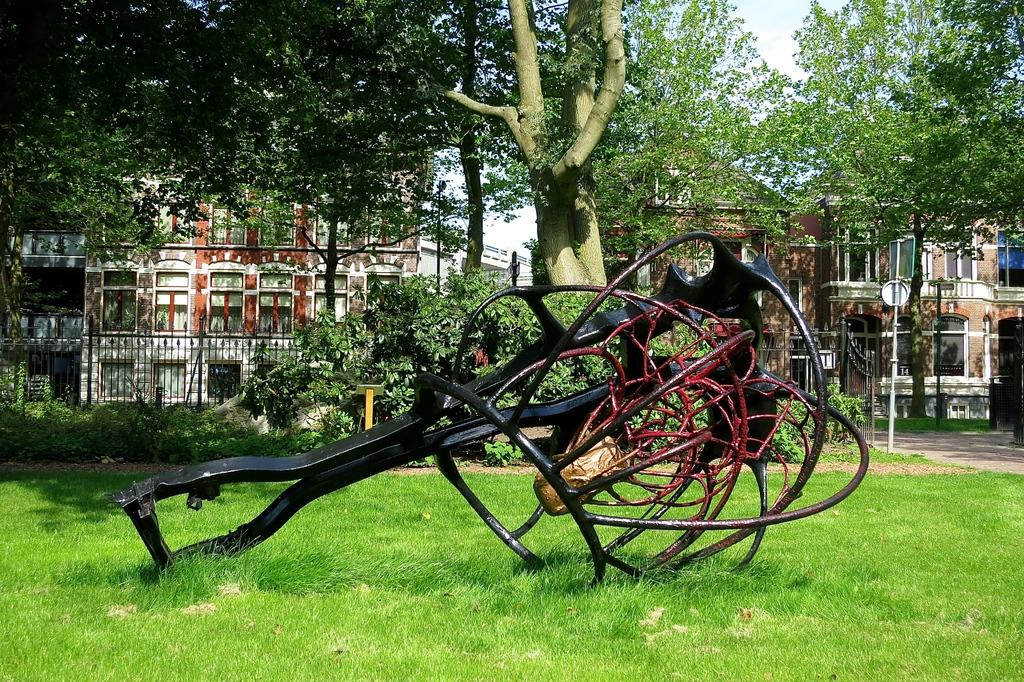What type of fence is in the image? There is an iron fence in the image. What is the iron fence situated on? The iron fence is on grass. What type of vegetation can be seen in the image? There are trees visible in the image. What type of structures can be seen in the image? There are buildings in the image. What else is present in the image besides the iron fence? Poles are present in the image. What is visible at the top of the image? The sky is visible at the top of the image. How much was the payment for the feast in the image? There is no payment or feast present in the image; it features an iron fence, grass, trees, buildings, poles, and the sky. What type of drain is visible in the image? There is no drain present in the image. 